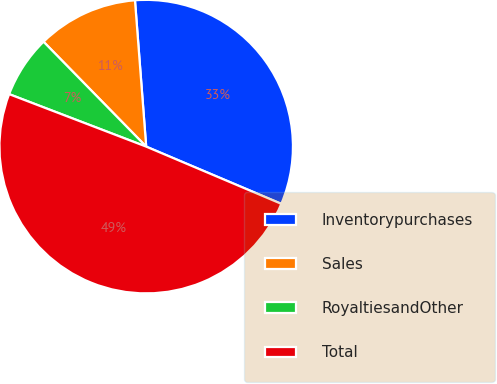Convert chart to OTSL. <chart><loc_0><loc_0><loc_500><loc_500><pie_chart><fcel>Inventorypurchases<fcel>Sales<fcel>RoyaltiesandOther<fcel>Total<nl><fcel>32.59%<fcel>11.11%<fcel>6.85%<fcel>49.44%<nl></chart> 